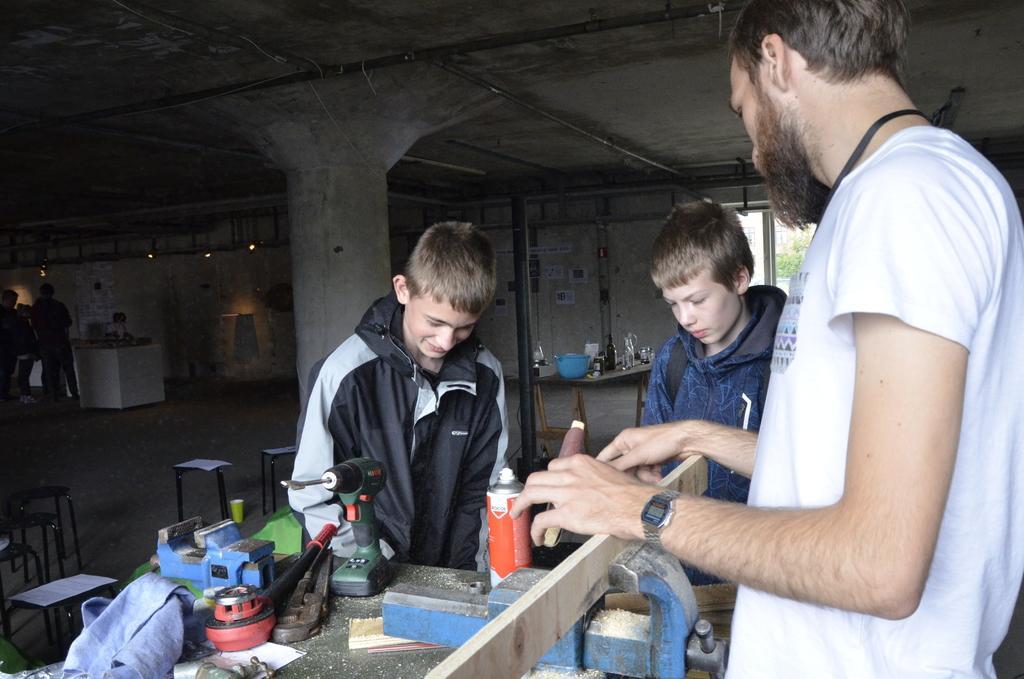Describe this image in one or two sentences. In this image we can see people standing on the floor and a table is placed in front of them. On the table there are carpentry tools, saw dust, cloth bag and a container. In the background there are persons standing on the floor, seating stools, table with containers on it and trees. 